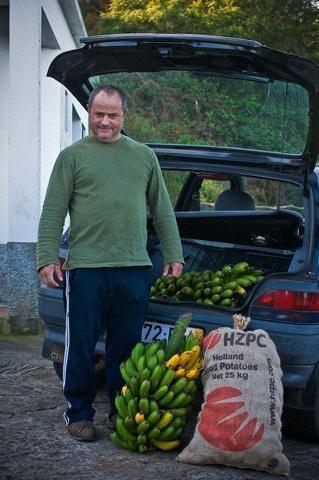How many bags of potatoes?
Give a very brief answer. 1. 